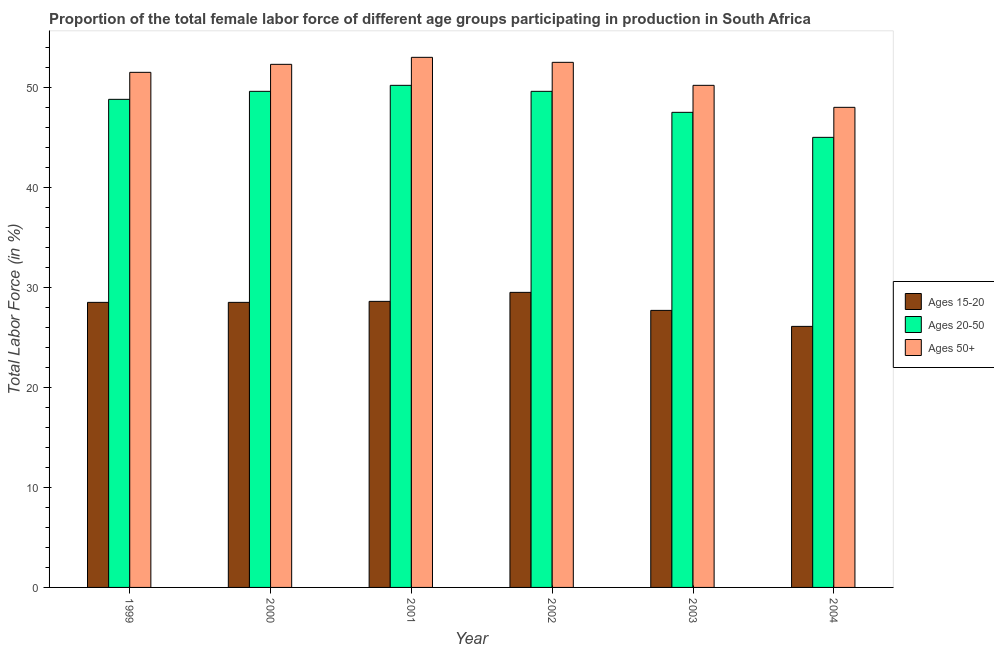How many different coloured bars are there?
Offer a very short reply. 3. How many groups of bars are there?
Offer a terse response. 6. Are the number of bars per tick equal to the number of legend labels?
Offer a very short reply. Yes. Are the number of bars on each tick of the X-axis equal?
Offer a terse response. Yes. How many bars are there on the 5th tick from the left?
Your answer should be compact. 3. How many bars are there on the 2nd tick from the right?
Ensure brevity in your answer.  3. What is the label of the 5th group of bars from the left?
Ensure brevity in your answer.  2003. What is the percentage of female labor force above age 50 in 2002?
Provide a succinct answer. 52.5. Across all years, what is the maximum percentage of female labor force within the age group 20-50?
Your response must be concise. 50.2. In which year was the percentage of female labor force within the age group 15-20 maximum?
Your answer should be compact. 2002. In which year was the percentage of female labor force above age 50 minimum?
Provide a succinct answer. 2004. What is the total percentage of female labor force above age 50 in the graph?
Offer a very short reply. 307.5. What is the difference between the percentage of female labor force above age 50 in 1999 and that in 2000?
Ensure brevity in your answer.  -0.8. What is the difference between the percentage of female labor force within the age group 20-50 in 1999 and the percentage of female labor force above age 50 in 2003?
Offer a terse response. 1.3. What is the average percentage of female labor force within the age group 15-20 per year?
Offer a very short reply. 28.15. In the year 2004, what is the difference between the percentage of female labor force above age 50 and percentage of female labor force within the age group 20-50?
Ensure brevity in your answer.  0. What is the ratio of the percentage of female labor force above age 50 in 2001 to that in 2002?
Give a very brief answer. 1.01. Is the percentage of female labor force within the age group 15-20 in 1999 less than that in 2000?
Your answer should be very brief. No. What is the difference between the highest and the second highest percentage of female labor force above age 50?
Make the answer very short. 0.5. What is the difference between the highest and the lowest percentage of female labor force within the age group 20-50?
Provide a short and direct response. 5.2. Is the sum of the percentage of female labor force within the age group 15-20 in 2000 and 2001 greater than the maximum percentage of female labor force above age 50 across all years?
Make the answer very short. Yes. What does the 2nd bar from the left in 2002 represents?
Make the answer very short. Ages 20-50. What does the 3rd bar from the right in 2001 represents?
Make the answer very short. Ages 15-20. Is it the case that in every year, the sum of the percentage of female labor force within the age group 15-20 and percentage of female labor force within the age group 20-50 is greater than the percentage of female labor force above age 50?
Make the answer very short. Yes. How many years are there in the graph?
Your response must be concise. 6. Are the values on the major ticks of Y-axis written in scientific E-notation?
Provide a short and direct response. No. Does the graph contain grids?
Your response must be concise. No. Where does the legend appear in the graph?
Your answer should be very brief. Center right. What is the title of the graph?
Offer a terse response. Proportion of the total female labor force of different age groups participating in production in South Africa. What is the label or title of the X-axis?
Make the answer very short. Year. What is the label or title of the Y-axis?
Provide a short and direct response. Total Labor Force (in %). What is the Total Labor Force (in %) in Ages 20-50 in 1999?
Your answer should be compact. 48.8. What is the Total Labor Force (in %) in Ages 50+ in 1999?
Your response must be concise. 51.5. What is the Total Labor Force (in %) of Ages 15-20 in 2000?
Provide a short and direct response. 28.5. What is the Total Labor Force (in %) in Ages 20-50 in 2000?
Your answer should be very brief. 49.6. What is the Total Labor Force (in %) in Ages 50+ in 2000?
Offer a terse response. 52.3. What is the Total Labor Force (in %) of Ages 15-20 in 2001?
Your response must be concise. 28.6. What is the Total Labor Force (in %) in Ages 20-50 in 2001?
Make the answer very short. 50.2. What is the Total Labor Force (in %) of Ages 50+ in 2001?
Offer a very short reply. 53. What is the Total Labor Force (in %) in Ages 15-20 in 2002?
Provide a succinct answer. 29.5. What is the Total Labor Force (in %) in Ages 20-50 in 2002?
Keep it short and to the point. 49.6. What is the Total Labor Force (in %) in Ages 50+ in 2002?
Ensure brevity in your answer.  52.5. What is the Total Labor Force (in %) of Ages 15-20 in 2003?
Provide a succinct answer. 27.7. What is the Total Labor Force (in %) in Ages 20-50 in 2003?
Provide a succinct answer. 47.5. What is the Total Labor Force (in %) of Ages 50+ in 2003?
Your answer should be compact. 50.2. What is the Total Labor Force (in %) of Ages 15-20 in 2004?
Ensure brevity in your answer.  26.1. What is the Total Labor Force (in %) in Ages 50+ in 2004?
Make the answer very short. 48. Across all years, what is the maximum Total Labor Force (in %) of Ages 15-20?
Ensure brevity in your answer.  29.5. Across all years, what is the maximum Total Labor Force (in %) of Ages 20-50?
Your answer should be compact. 50.2. Across all years, what is the minimum Total Labor Force (in %) of Ages 15-20?
Provide a succinct answer. 26.1. Across all years, what is the minimum Total Labor Force (in %) in Ages 50+?
Offer a very short reply. 48. What is the total Total Labor Force (in %) of Ages 15-20 in the graph?
Give a very brief answer. 168.9. What is the total Total Labor Force (in %) in Ages 20-50 in the graph?
Your response must be concise. 290.7. What is the total Total Labor Force (in %) of Ages 50+ in the graph?
Provide a succinct answer. 307.5. What is the difference between the Total Labor Force (in %) of Ages 15-20 in 1999 and that in 2000?
Your answer should be very brief. 0. What is the difference between the Total Labor Force (in %) of Ages 20-50 in 1999 and that in 2000?
Make the answer very short. -0.8. What is the difference between the Total Labor Force (in %) in Ages 20-50 in 1999 and that in 2001?
Your answer should be very brief. -1.4. What is the difference between the Total Labor Force (in %) of Ages 50+ in 1999 and that in 2001?
Your answer should be very brief. -1.5. What is the difference between the Total Labor Force (in %) in Ages 15-20 in 1999 and that in 2003?
Make the answer very short. 0.8. What is the difference between the Total Labor Force (in %) in Ages 15-20 in 1999 and that in 2004?
Ensure brevity in your answer.  2.4. What is the difference between the Total Labor Force (in %) in Ages 20-50 in 1999 and that in 2004?
Provide a short and direct response. 3.8. What is the difference between the Total Labor Force (in %) of Ages 15-20 in 2000 and that in 2001?
Your answer should be very brief. -0.1. What is the difference between the Total Labor Force (in %) of Ages 50+ in 2000 and that in 2001?
Make the answer very short. -0.7. What is the difference between the Total Labor Force (in %) in Ages 15-20 in 2000 and that in 2002?
Provide a succinct answer. -1. What is the difference between the Total Labor Force (in %) in Ages 50+ in 2000 and that in 2002?
Keep it short and to the point. -0.2. What is the difference between the Total Labor Force (in %) in Ages 15-20 in 2000 and that in 2003?
Your response must be concise. 0.8. What is the difference between the Total Labor Force (in %) of Ages 20-50 in 2000 and that in 2003?
Provide a succinct answer. 2.1. What is the difference between the Total Labor Force (in %) in Ages 15-20 in 2000 and that in 2004?
Keep it short and to the point. 2.4. What is the difference between the Total Labor Force (in %) of Ages 20-50 in 2000 and that in 2004?
Provide a succinct answer. 4.6. What is the difference between the Total Labor Force (in %) of Ages 50+ in 2001 and that in 2002?
Your answer should be compact. 0.5. What is the difference between the Total Labor Force (in %) of Ages 20-50 in 2001 and that in 2003?
Provide a succinct answer. 2.7. What is the difference between the Total Labor Force (in %) of Ages 20-50 in 2001 and that in 2004?
Offer a terse response. 5.2. What is the difference between the Total Labor Force (in %) in Ages 50+ in 2002 and that in 2004?
Your answer should be compact. 4.5. What is the difference between the Total Labor Force (in %) of Ages 15-20 in 2003 and that in 2004?
Ensure brevity in your answer.  1.6. What is the difference between the Total Labor Force (in %) of Ages 20-50 in 2003 and that in 2004?
Keep it short and to the point. 2.5. What is the difference between the Total Labor Force (in %) in Ages 15-20 in 1999 and the Total Labor Force (in %) in Ages 20-50 in 2000?
Provide a succinct answer. -21.1. What is the difference between the Total Labor Force (in %) in Ages 15-20 in 1999 and the Total Labor Force (in %) in Ages 50+ in 2000?
Your answer should be compact. -23.8. What is the difference between the Total Labor Force (in %) of Ages 15-20 in 1999 and the Total Labor Force (in %) of Ages 20-50 in 2001?
Provide a succinct answer. -21.7. What is the difference between the Total Labor Force (in %) in Ages 15-20 in 1999 and the Total Labor Force (in %) in Ages 50+ in 2001?
Make the answer very short. -24.5. What is the difference between the Total Labor Force (in %) of Ages 20-50 in 1999 and the Total Labor Force (in %) of Ages 50+ in 2001?
Provide a succinct answer. -4.2. What is the difference between the Total Labor Force (in %) in Ages 15-20 in 1999 and the Total Labor Force (in %) in Ages 20-50 in 2002?
Make the answer very short. -21.1. What is the difference between the Total Labor Force (in %) of Ages 15-20 in 1999 and the Total Labor Force (in %) of Ages 50+ in 2003?
Your answer should be compact. -21.7. What is the difference between the Total Labor Force (in %) of Ages 20-50 in 1999 and the Total Labor Force (in %) of Ages 50+ in 2003?
Provide a succinct answer. -1.4. What is the difference between the Total Labor Force (in %) of Ages 15-20 in 1999 and the Total Labor Force (in %) of Ages 20-50 in 2004?
Make the answer very short. -16.5. What is the difference between the Total Labor Force (in %) of Ages 15-20 in 1999 and the Total Labor Force (in %) of Ages 50+ in 2004?
Your response must be concise. -19.5. What is the difference between the Total Labor Force (in %) of Ages 15-20 in 2000 and the Total Labor Force (in %) of Ages 20-50 in 2001?
Keep it short and to the point. -21.7. What is the difference between the Total Labor Force (in %) in Ages 15-20 in 2000 and the Total Labor Force (in %) in Ages 50+ in 2001?
Your answer should be compact. -24.5. What is the difference between the Total Labor Force (in %) of Ages 15-20 in 2000 and the Total Labor Force (in %) of Ages 20-50 in 2002?
Give a very brief answer. -21.1. What is the difference between the Total Labor Force (in %) in Ages 15-20 in 2000 and the Total Labor Force (in %) in Ages 50+ in 2002?
Provide a succinct answer. -24. What is the difference between the Total Labor Force (in %) in Ages 15-20 in 2000 and the Total Labor Force (in %) in Ages 50+ in 2003?
Ensure brevity in your answer.  -21.7. What is the difference between the Total Labor Force (in %) in Ages 20-50 in 2000 and the Total Labor Force (in %) in Ages 50+ in 2003?
Your answer should be compact. -0.6. What is the difference between the Total Labor Force (in %) of Ages 15-20 in 2000 and the Total Labor Force (in %) of Ages 20-50 in 2004?
Make the answer very short. -16.5. What is the difference between the Total Labor Force (in %) of Ages 15-20 in 2000 and the Total Labor Force (in %) of Ages 50+ in 2004?
Your answer should be compact. -19.5. What is the difference between the Total Labor Force (in %) of Ages 15-20 in 2001 and the Total Labor Force (in %) of Ages 20-50 in 2002?
Keep it short and to the point. -21. What is the difference between the Total Labor Force (in %) of Ages 15-20 in 2001 and the Total Labor Force (in %) of Ages 50+ in 2002?
Your answer should be very brief. -23.9. What is the difference between the Total Labor Force (in %) of Ages 15-20 in 2001 and the Total Labor Force (in %) of Ages 20-50 in 2003?
Offer a terse response. -18.9. What is the difference between the Total Labor Force (in %) of Ages 15-20 in 2001 and the Total Labor Force (in %) of Ages 50+ in 2003?
Your answer should be very brief. -21.6. What is the difference between the Total Labor Force (in %) in Ages 15-20 in 2001 and the Total Labor Force (in %) in Ages 20-50 in 2004?
Provide a short and direct response. -16.4. What is the difference between the Total Labor Force (in %) in Ages 15-20 in 2001 and the Total Labor Force (in %) in Ages 50+ in 2004?
Your answer should be very brief. -19.4. What is the difference between the Total Labor Force (in %) of Ages 15-20 in 2002 and the Total Labor Force (in %) of Ages 50+ in 2003?
Provide a succinct answer. -20.7. What is the difference between the Total Labor Force (in %) of Ages 20-50 in 2002 and the Total Labor Force (in %) of Ages 50+ in 2003?
Your answer should be very brief. -0.6. What is the difference between the Total Labor Force (in %) of Ages 15-20 in 2002 and the Total Labor Force (in %) of Ages 20-50 in 2004?
Your response must be concise. -15.5. What is the difference between the Total Labor Force (in %) of Ages 15-20 in 2002 and the Total Labor Force (in %) of Ages 50+ in 2004?
Your response must be concise. -18.5. What is the difference between the Total Labor Force (in %) of Ages 15-20 in 2003 and the Total Labor Force (in %) of Ages 20-50 in 2004?
Offer a terse response. -17.3. What is the difference between the Total Labor Force (in %) of Ages 15-20 in 2003 and the Total Labor Force (in %) of Ages 50+ in 2004?
Your answer should be compact. -20.3. What is the difference between the Total Labor Force (in %) in Ages 20-50 in 2003 and the Total Labor Force (in %) in Ages 50+ in 2004?
Your answer should be compact. -0.5. What is the average Total Labor Force (in %) in Ages 15-20 per year?
Offer a terse response. 28.15. What is the average Total Labor Force (in %) in Ages 20-50 per year?
Offer a terse response. 48.45. What is the average Total Labor Force (in %) of Ages 50+ per year?
Your answer should be very brief. 51.25. In the year 1999, what is the difference between the Total Labor Force (in %) of Ages 15-20 and Total Labor Force (in %) of Ages 20-50?
Your answer should be very brief. -20.3. In the year 1999, what is the difference between the Total Labor Force (in %) in Ages 15-20 and Total Labor Force (in %) in Ages 50+?
Give a very brief answer. -23. In the year 2000, what is the difference between the Total Labor Force (in %) in Ages 15-20 and Total Labor Force (in %) in Ages 20-50?
Make the answer very short. -21.1. In the year 2000, what is the difference between the Total Labor Force (in %) in Ages 15-20 and Total Labor Force (in %) in Ages 50+?
Offer a very short reply. -23.8. In the year 2001, what is the difference between the Total Labor Force (in %) in Ages 15-20 and Total Labor Force (in %) in Ages 20-50?
Give a very brief answer. -21.6. In the year 2001, what is the difference between the Total Labor Force (in %) in Ages 15-20 and Total Labor Force (in %) in Ages 50+?
Your answer should be compact. -24.4. In the year 2001, what is the difference between the Total Labor Force (in %) in Ages 20-50 and Total Labor Force (in %) in Ages 50+?
Offer a terse response. -2.8. In the year 2002, what is the difference between the Total Labor Force (in %) in Ages 15-20 and Total Labor Force (in %) in Ages 20-50?
Offer a terse response. -20.1. In the year 2002, what is the difference between the Total Labor Force (in %) in Ages 15-20 and Total Labor Force (in %) in Ages 50+?
Keep it short and to the point. -23. In the year 2003, what is the difference between the Total Labor Force (in %) of Ages 15-20 and Total Labor Force (in %) of Ages 20-50?
Provide a short and direct response. -19.8. In the year 2003, what is the difference between the Total Labor Force (in %) of Ages 15-20 and Total Labor Force (in %) of Ages 50+?
Offer a terse response. -22.5. In the year 2004, what is the difference between the Total Labor Force (in %) in Ages 15-20 and Total Labor Force (in %) in Ages 20-50?
Offer a very short reply. -18.9. In the year 2004, what is the difference between the Total Labor Force (in %) in Ages 15-20 and Total Labor Force (in %) in Ages 50+?
Keep it short and to the point. -21.9. What is the ratio of the Total Labor Force (in %) of Ages 15-20 in 1999 to that in 2000?
Provide a short and direct response. 1. What is the ratio of the Total Labor Force (in %) of Ages 20-50 in 1999 to that in 2000?
Keep it short and to the point. 0.98. What is the ratio of the Total Labor Force (in %) in Ages 50+ in 1999 to that in 2000?
Provide a succinct answer. 0.98. What is the ratio of the Total Labor Force (in %) in Ages 15-20 in 1999 to that in 2001?
Provide a short and direct response. 1. What is the ratio of the Total Labor Force (in %) in Ages 20-50 in 1999 to that in 2001?
Make the answer very short. 0.97. What is the ratio of the Total Labor Force (in %) of Ages 50+ in 1999 to that in 2001?
Provide a short and direct response. 0.97. What is the ratio of the Total Labor Force (in %) of Ages 15-20 in 1999 to that in 2002?
Ensure brevity in your answer.  0.97. What is the ratio of the Total Labor Force (in %) of Ages 20-50 in 1999 to that in 2002?
Ensure brevity in your answer.  0.98. What is the ratio of the Total Labor Force (in %) of Ages 15-20 in 1999 to that in 2003?
Ensure brevity in your answer.  1.03. What is the ratio of the Total Labor Force (in %) of Ages 20-50 in 1999 to that in 2003?
Provide a short and direct response. 1.03. What is the ratio of the Total Labor Force (in %) in Ages 50+ in 1999 to that in 2003?
Give a very brief answer. 1.03. What is the ratio of the Total Labor Force (in %) of Ages 15-20 in 1999 to that in 2004?
Make the answer very short. 1.09. What is the ratio of the Total Labor Force (in %) in Ages 20-50 in 1999 to that in 2004?
Your response must be concise. 1.08. What is the ratio of the Total Labor Force (in %) of Ages 50+ in 1999 to that in 2004?
Ensure brevity in your answer.  1.07. What is the ratio of the Total Labor Force (in %) of Ages 20-50 in 2000 to that in 2001?
Your response must be concise. 0.99. What is the ratio of the Total Labor Force (in %) in Ages 50+ in 2000 to that in 2001?
Your answer should be compact. 0.99. What is the ratio of the Total Labor Force (in %) of Ages 15-20 in 2000 to that in 2002?
Your answer should be very brief. 0.97. What is the ratio of the Total Labor Force (in %) in Ages 20-50 in 2000 to that in 2002?
Offer a terse response. 1. What is the ratio of the Total Labor Force (in %) in Ages 15-20 in 2000 to that in 2003?
Offer a very short reply. 1.03. What is the ratio of the Total Labor Force (in %) in Ages 20-50 in 2000 to that in 2003?
Offer a very short reply. 1.04. What is the ratio of the Total Labor Force (in %) in Ages 50+ in 2000 to that in 2003?
Provide a short and direct response. 1.04. What is the ratio of the Total Labor Force (in %) in Ages 15-20 in 2000 to that in 2004?
Provide a succinct answer. 1.09. What is the ratio of the Total Labor Force (in %) in Ages 20-50 in 2000 to that in 2004?
Provide a short and direct response. 1.1. What is the ratio of the Total Labor Force (in %) in Ages 50+ in 2000 to that in 2004?
Your response must be concise. 1.09. What is the ratio of the Total Labor Force (in %) of Ages 15-20 in 2001 to that in 2002?
Your answer should be compact. 0.97. What is the ratio of the Total Labor Force (in %) of Ages 20-50 in 2001 to that in 2002?
Keep it short and to the point. 1.01. What is the ratio of the Total Labor Force (in %) in Ages 50+ in 2001 to that in 2002?
Keep it short and to the point. 1.01. What is the ratio of the Total Labor Force (in %) in Ages 15-20 in 2001 to that in 2003?
Keep it short and to the point. 1.03. What is the ratio of the Total Labor Force (in %) of Ages 20-50 in 2001 to that in 2003?
Provide a succinct answer. 1.06. What is the ratio of the Total Labor Force (in %) of Ages 50+ in 2001 to that in 2003?
Provide a succinct answer. 1.06. What is the ratio of the Total Labor Force (in %) of Ages 15-20 in 2001 to that in 2004?
Offer a terse response. 1.1. What is the ratio of the Total Labor Force (in %) in Ages 20-50 in 2001 to that in 2004?
Give a very brief answer. 1.12. What is the ratio of the Total Labor Force (in %) in Ages 50+ in 2001 to that in 2004?
Your answer should be compact. 1.1. What is the ratio of the Total Labor Force (in %) of Ages 15-20 in 2002 to that in 2003?
Offer a very short reply. 1.06. What is the ratio of the Total Labor Force (in %) in Ages 20-50 in 2002 to that in 2003?
Offer a terse response. 1.04. What is the ratio of the Total Labor Force (in %) in Ages 50+ in 2002 to that in 2003?
Offer a very short reply. 1.05. What is the ratio of the Total Labor Force (in %) in Ages 15-20 in 2002 to that in 2004?
Keep it short and to the point. 1.13. What is the ratio of the Total Labor Force (in %) in Ages 20-50 in 2002 to that in 2004?
Offer a very short reply. 1.1. What is the ratio of the Total Labor Force (in %) in Ages 50+ in 2002 to that in 2004?
Make the answer very short. 1.09. What is the ratio of the Total Labor Force (in %) of Ages 15-20 in 2003 to that in 2004?
Your answer should be compact. 1.06. What is the ratio of the Total Labor Force (in %) in Ages 20-50 in 2003 to that in 2004?
Provide a succinct answer. 1.06. What is the ratio of the Total Labor Force (in %) of Ages 50+ in 2003 to that in 2004?
Offer a very short reply. 1.05. 